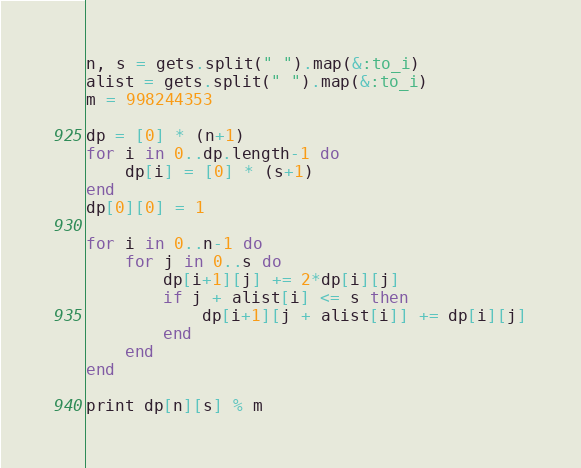Convert code to text. <code><loc_0><loc_0><loc_500><loc_500><_Ruby_>n, s = gets.split(" ").map(&:to_i)
alist = gets.split(" ").map(&:to_i)
m = 998244353

dp = [0] * (n+1)
for i in 0..dp.length-1 do
    dp[i] = [0] * (s+1)
end
dp[0][0] = 1

for i in 0..n-1 do
    for j in 0..s do
        dp[i+1][j] += 2*dp[i][j]
        if j + alist[i] <= s then 
            dp[i+1][j + alist[i]] += dp[i][j]
        end     
    end
end

print dp[n][s] % m </code> 